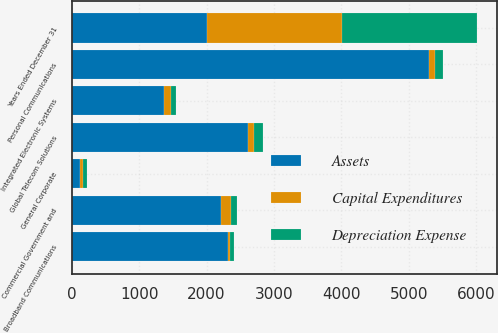Convert chart. <chart><loc_0><loc_0><loc_500><loc_500><stacked_bar_chart><ecel><fcel>Years Ended December 31<fcel>Personal Communications<fcel>Global Telecom Solutions<fcel>Commercial Government and<fcel>Integrated Electronic Systems<fcel>Broadband Communications<fcel>General Corporate<nl><fcel>Assets<fcel>2004<fcel>5292<fcel>2616<fcel>2215<fcel>1368<fcel>2314<fcel>128.5<nl><fcel>Capital Expenditures<fcel>2004<fcel>91<fcel>91<fcel>149<fcel>99<fcel>27<fcel>37<nl><fcel>Depreciation Expense<fcel>2004<fcel>128<fcel>129<fcel>90<fcel>77<fcel>59<fcel>65<nl></chart> 